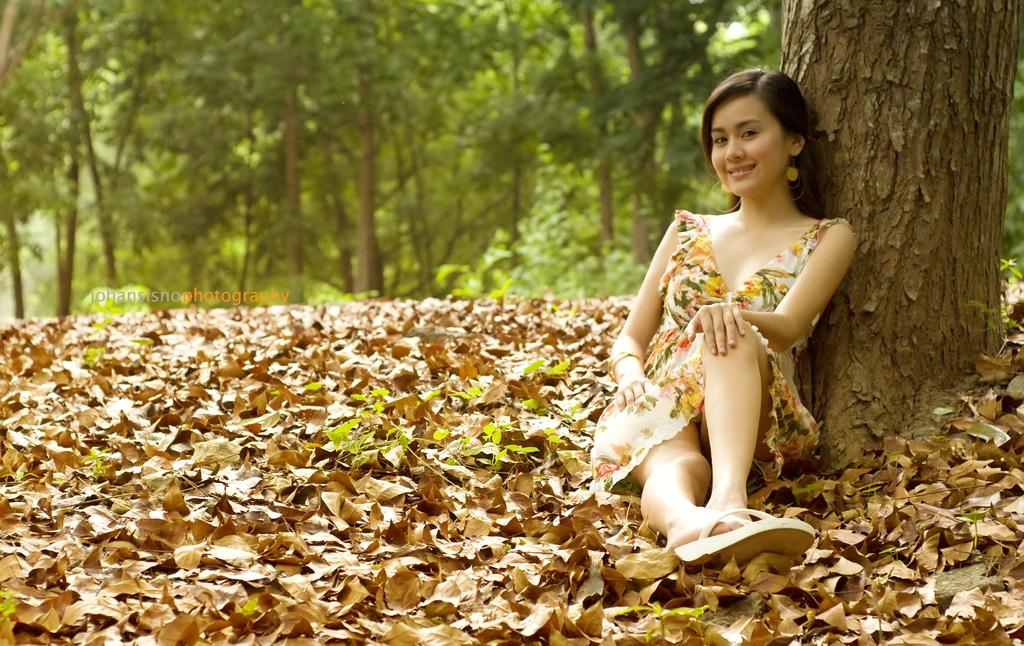Who is the main subject in the image? There is a lady in the image. What type of natural environment is depicted in the image? There are many trees and dry leaves present in the image, suggesting a forest or wooded area. Can you describe the tree trunk visible in the image? Yes, there is a trunk of a tree at the right side of the image. What type of bait is the lady using to catch fish in the image? There is no indication of fishing or bait in the image; it primarily features a lady and a natural environment with trees and dry leaves. 